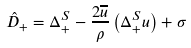Convert formula to latex. <formula><loc_0><loc_0><loc_500><loc_500>\hat { D } _ { + } = \Delta ^ { S } _ { + } - \frac { 2 \overline { u } } { \rho } \left ( \Delta ^ { S } _ { + } u \right ) + \sigma</formula> 